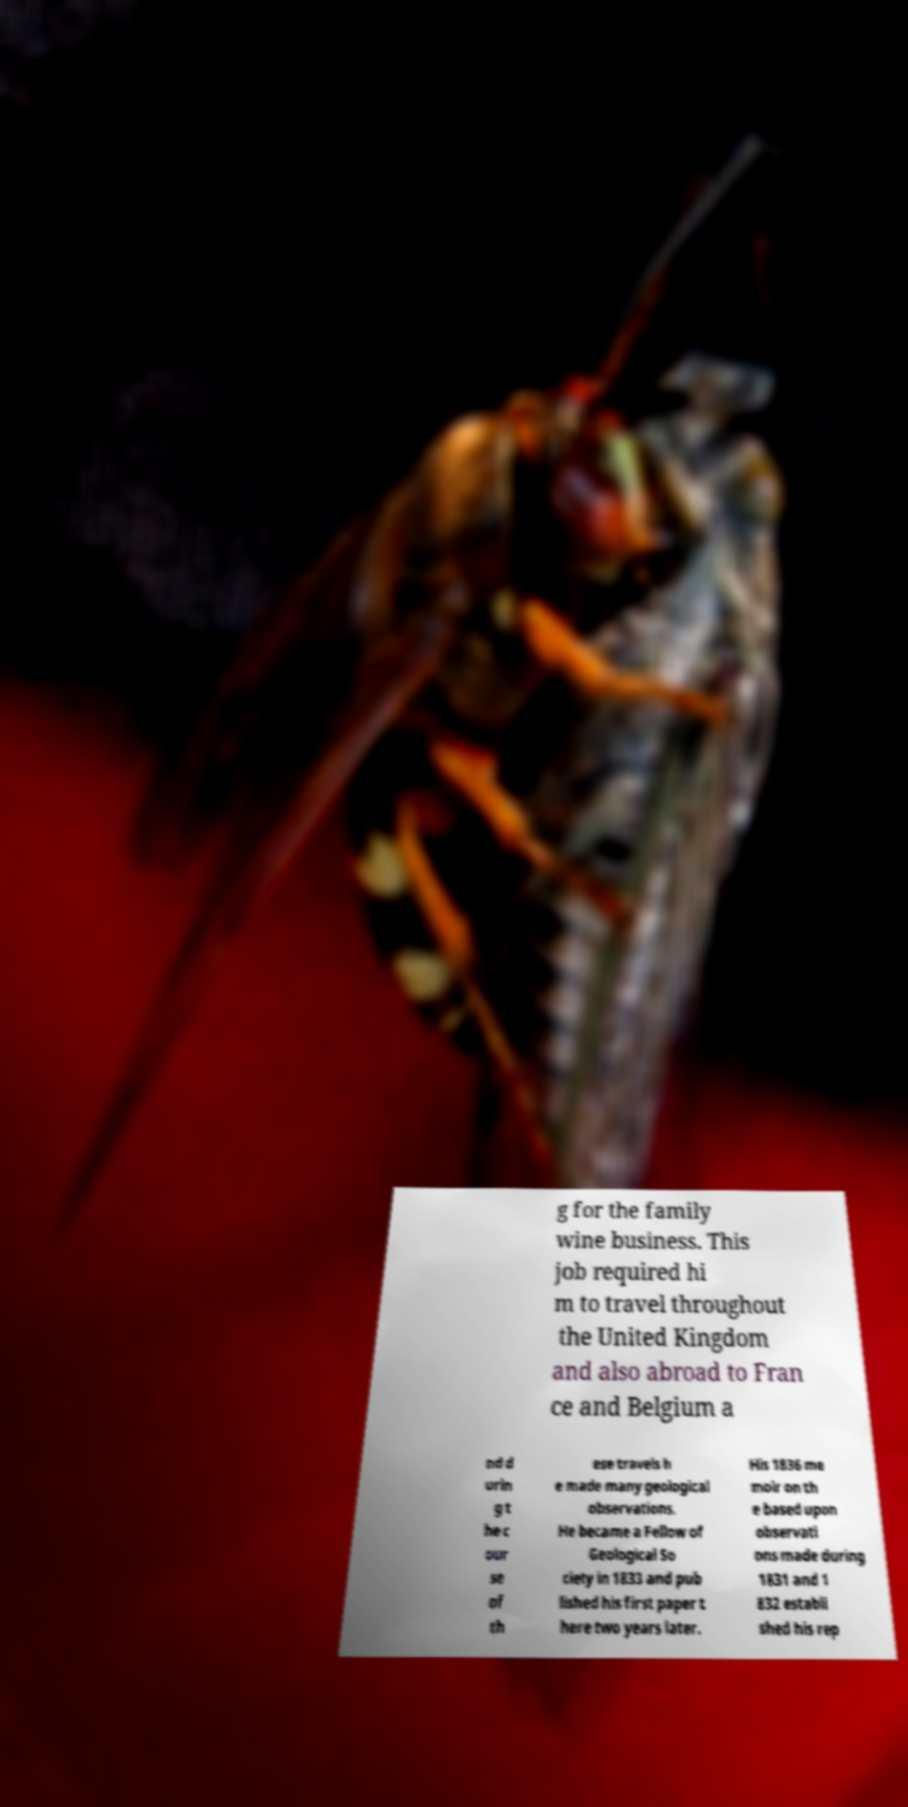I need the written content from this picture converted into text. Can you do that? g for the family wine business. This job required hi m to travel throughout the United Kingdom and also abroad to Fran ce and Belgium a nd d urin g t he c our se of th ese travels h e made many geological observations. He became a Fellow of Geological So ciety in 1833 and pub lished his first paper t here two years later. His 1836 me moir on th e based upon observati ons made during 1831 and 1 832 establi shed his rep 